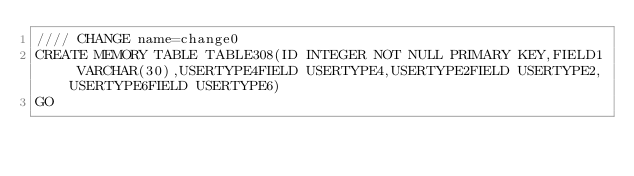<code> <loc_0><loc_0><loc_500><loc_500><_SQL_>//// CHANGE name=change0
CREATE MEMORY TABLE TABLE308(ID INTEGER NOT NULL PRIMARY KEY,FIELD1 VARCHAR(30),USERTYPE4FIELD USERTYPE4,USERTYPE2FIELD USERTYPE2,USERTYPE6FIELD USERTYPE6)
GO
</code> 